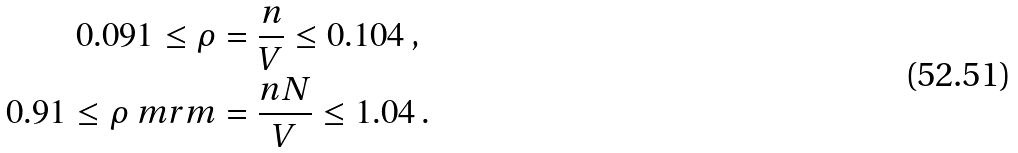Convert formula to latex. <formula><loc_0><loc_0><loc_500><loc_500>0 . 0 9 1 \leq \rho & = \frac { n } { V } \leq 0 . 1 0 4 \, , \\ 0 . 9 1 \leq \rho _ { \ } m r { m } & = \frac { n N } { V } \leq 1 . 0 4 \, .</formula> 